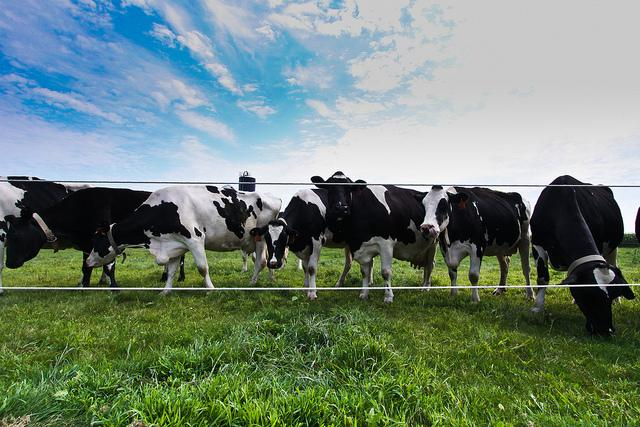What type of fence is shown here?

Choices:
A) wood stockade
B) none
C) electrified
D) barbed wire electrified 